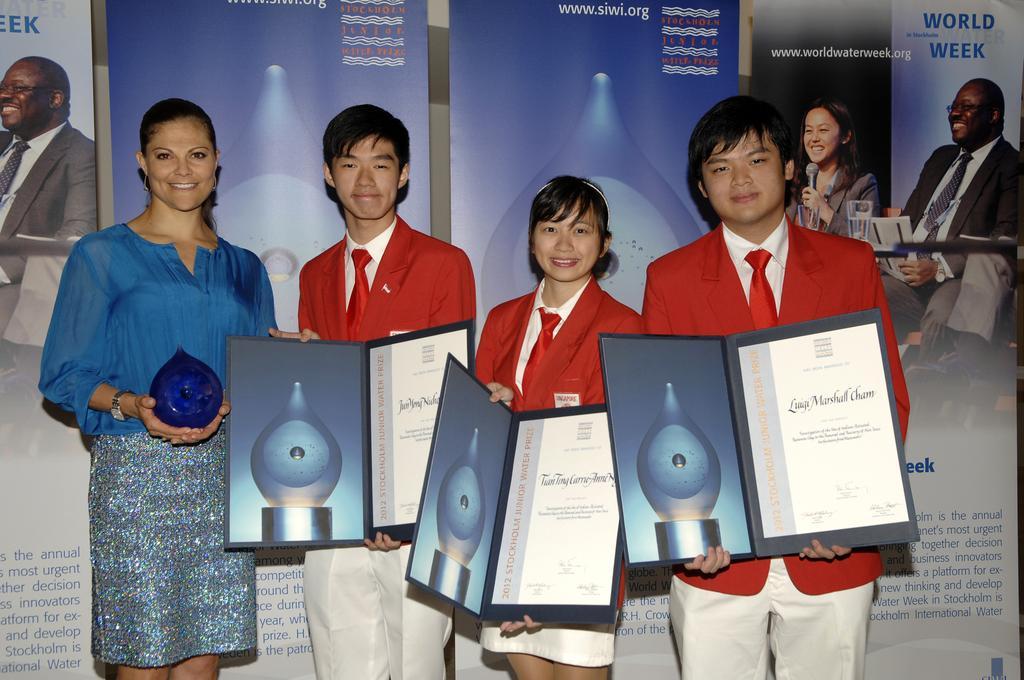Please provide a concise description of this image. In this image there are people standing. Left side there is a woman holding an object. Three people are holding the boards which are having some text. Behind them there are banners attached to the wall. On the banners there are photos of people and some text. 